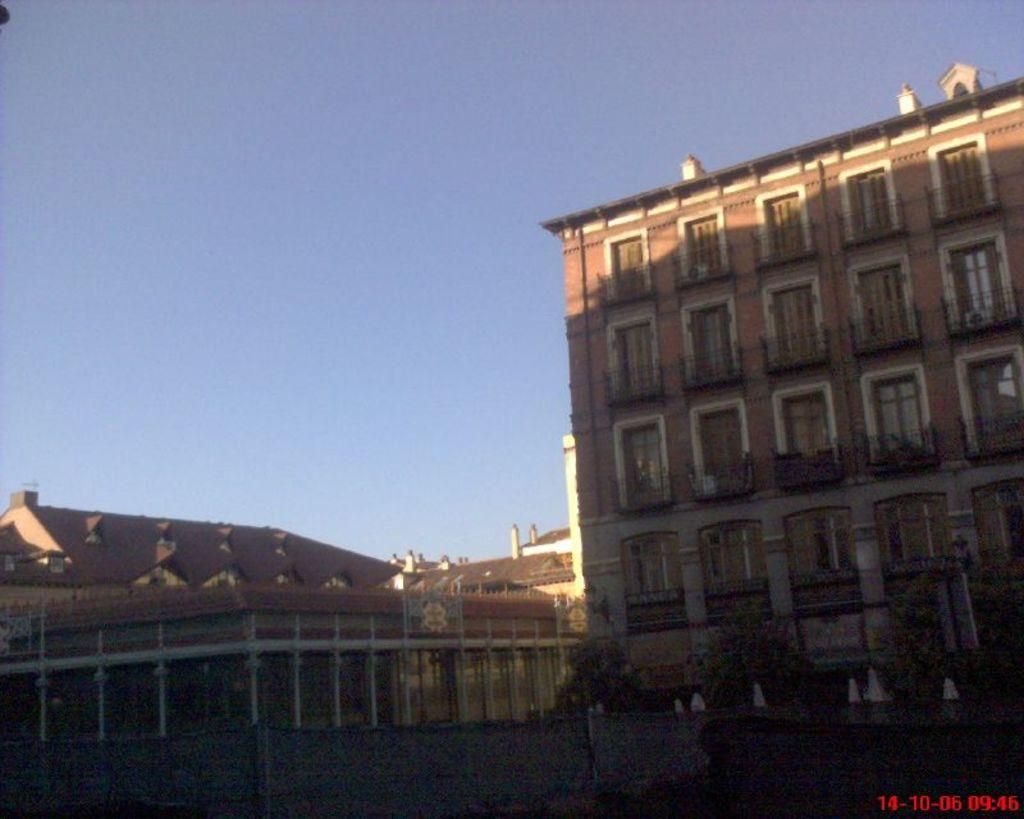What type of structures can be seen in the image? There are buildings in the image. What other natural elements are present in the image? There are trees in the image. What is at the bottom of the image? There is a wall at the bottom of the image. What can be seen in the distance in the image? The sky is visible in the background of the image. What type of silk is being used to make the hospital gowns in the image? There is no hospital or silk present in the image; it features buildings, trees, a wall, and the sky. 